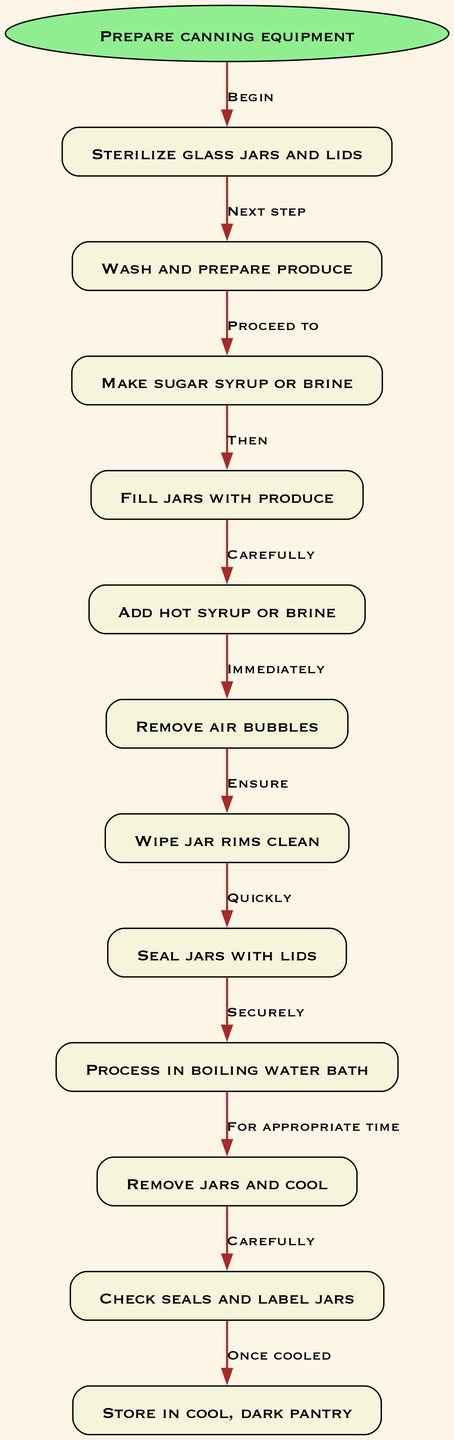What's the first step in the canning process? The first step, as indicated in the diagram, is "Prepare canning equipment." This is the starting node, which leads directly into the next steps in the process.
Answer: Prepare canning equipment How many total nodes are present in the diagram? The diagram shows a total of 12 nodes, including the starting node and the 11 subsequent steps involved in the canning process.
Answer: 12 What is the last step in the preservation process? According to the diagram, the final step is "Store in cool, dark pantry." This is the last node, demonstrating where the preserved produce should be kept.
Answer: Store in cool, dark pantry Which step follows 'Seal jars with lids'? Following the node "Seal jars with lids," the next step is indicated as "Process in boiling water bath," based on the sequential flow established in the diagram.
Answer: Process in boiling water bath What is done immediately after removing jars from the boiling water bath? After removing the jars from the boiling water bath, the next action is "Remove jars and cool," indicating the need to let them cool down before checking their seals.
Answer: Remove jars and cool How many edges are connecting the nodes? The diagram contains 11 edges, correlating directly with the number of transitions between the 12 nodes (each edge representing the progression from one step to the next).
Answer: 11 What must be done before adding hot syrup or brine? Prior to adding hot syrup or brine, it is essential to "Fill jars with produce." This sequence shows the importance of preparing the jars before pouring the liquid.
Answer: Fill jars with produce Which step ensures that there are no air bubbles? The step that addresses removing air bubbles is "Remove air bubbles," which is crucial for ensuring the preservation quality and safety of the canned produce.
Answer: Remove air bubbles What action is taken right after adding hot syrup or brine? After hot syrup or brine is added, the subsequent step is "Wipe jar rims clean," which is necessary for a proper seal.
Answer: Wipe jar rims clean 